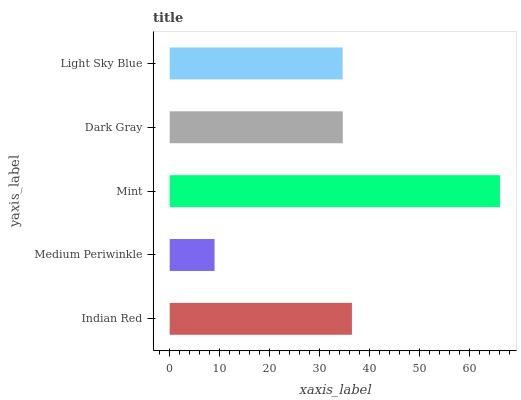Is Medium Periwinkle the minimum?
Answer yes or no. Yes. Is Mint the maximum?
Answer yes or no. Yes. Is Mint the minimum?
Answer yes or no. No. Is Medium Periwinkle the maximum?
Answer yes or no. No. Is Mint greater than Medium Periwinkle?
Answer yes or no. Yes. Is Medium Periwinkle less than Mint?
Answer yes or no. Yes. Is Medium Periwinkle greater than Mint?
Answer yes or no. No. Is Mint less than Medium Periwinkle?
Answer yes or no. No. Is Dark Gray the high median?
Answer yes or no. Yes. Is Dark Gray the low median?
Answer yes or no. Yes. Is Light Sky Blue the high median?
Answer yes or no. No. Is Medium Periwinkle the low median?
Answer yes or no. No. 